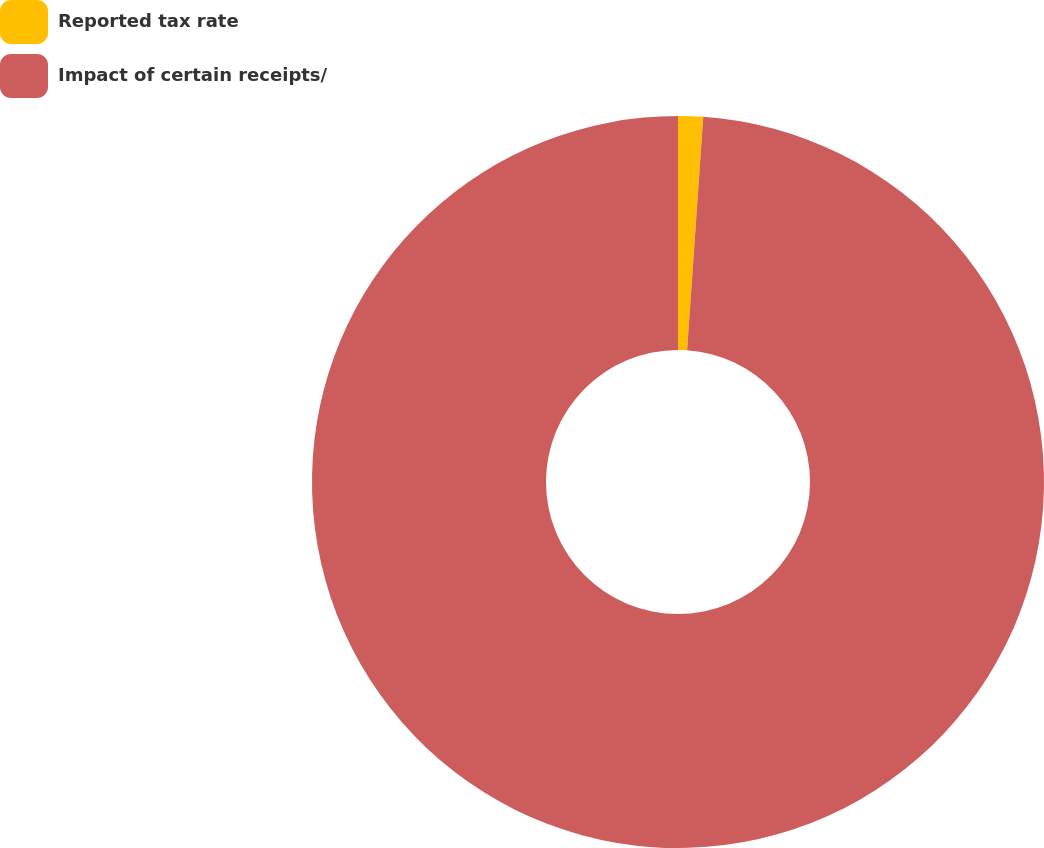<chart> <loc_0><loc_0><loc_500><loc_500><pie_chart><fcel>Reported tax rate<fcel>Impact of certain receipts/<nl><fcel>1.1%<fcel>98.9%<nl></chart> 